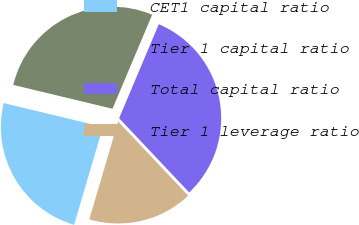Convert chart to OTSL. <chart><loc_0><loc_0><loc_500><loc_500><pie_chart><fcel>CET1 capital ratio<fcel>Tier 1 capital ratio<fcel>Total capital ratio<fcel>Tier 1 leverage ratio<nl><fcel>24.2%<fcel>27.6%<fcel>31.6%<fcel>16.6%<nl></chart> 